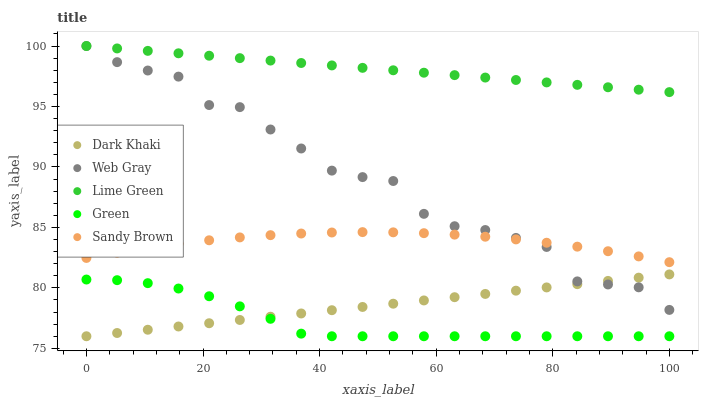Does Green have the minimum area under the curve?
Answer yes or no. Yes. Does Lime Green have the maximum area under the curve?
Answer yes or no. Yes. Does Web Gray have the minimum area under the curve?
Answer yes or no. No. Does Web Gray have the maximum area under the curve?
Answer yes or no. No. Is Dark Khaki the smoothest?
Answer yes or no. Yes. Is Web Gray the roughest?
Answer yes or no. Yes. Is Green the smoothest?
Answer yes or no. No. Is Green the roughest?
Answer yes or no. No. Does Dark Khaki have the lowest value?
Answer yes or no. Yes. Does Web Gray have the lowest value?
Answer yes or no. No. Does Lime Green have the highest value?
Answer yes or no. Yes. Does Green have the highest value?
Answer yes or no. No. Is Dark Khaki less than Lime Green?
Answer yes or no. Yes. Is Sandy Brown greater than Dark Khaki?
Answer yes or no. Yes. Does Lime Green intersect Web Gray?
Answer yes or no. Yes. Is Lime Green less than Web Gray?
Answer yes or no. No. Is Lime Green greater than Web Gray?
Answer yes or no. No. Does Dark Khaki intersect Lime Green?
Answer yes or no. No. 